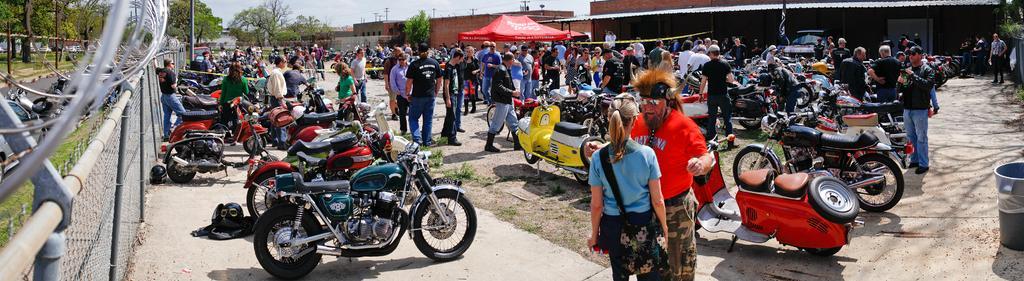Could you give a brief overview of what you see in this image? In this picture we can see helmets, bikes, tent, buildings, poles, trees, fence, road, grass, dust bin, vehicle and a group of people standing on the ground and some objects and in the background we can see the sky. 